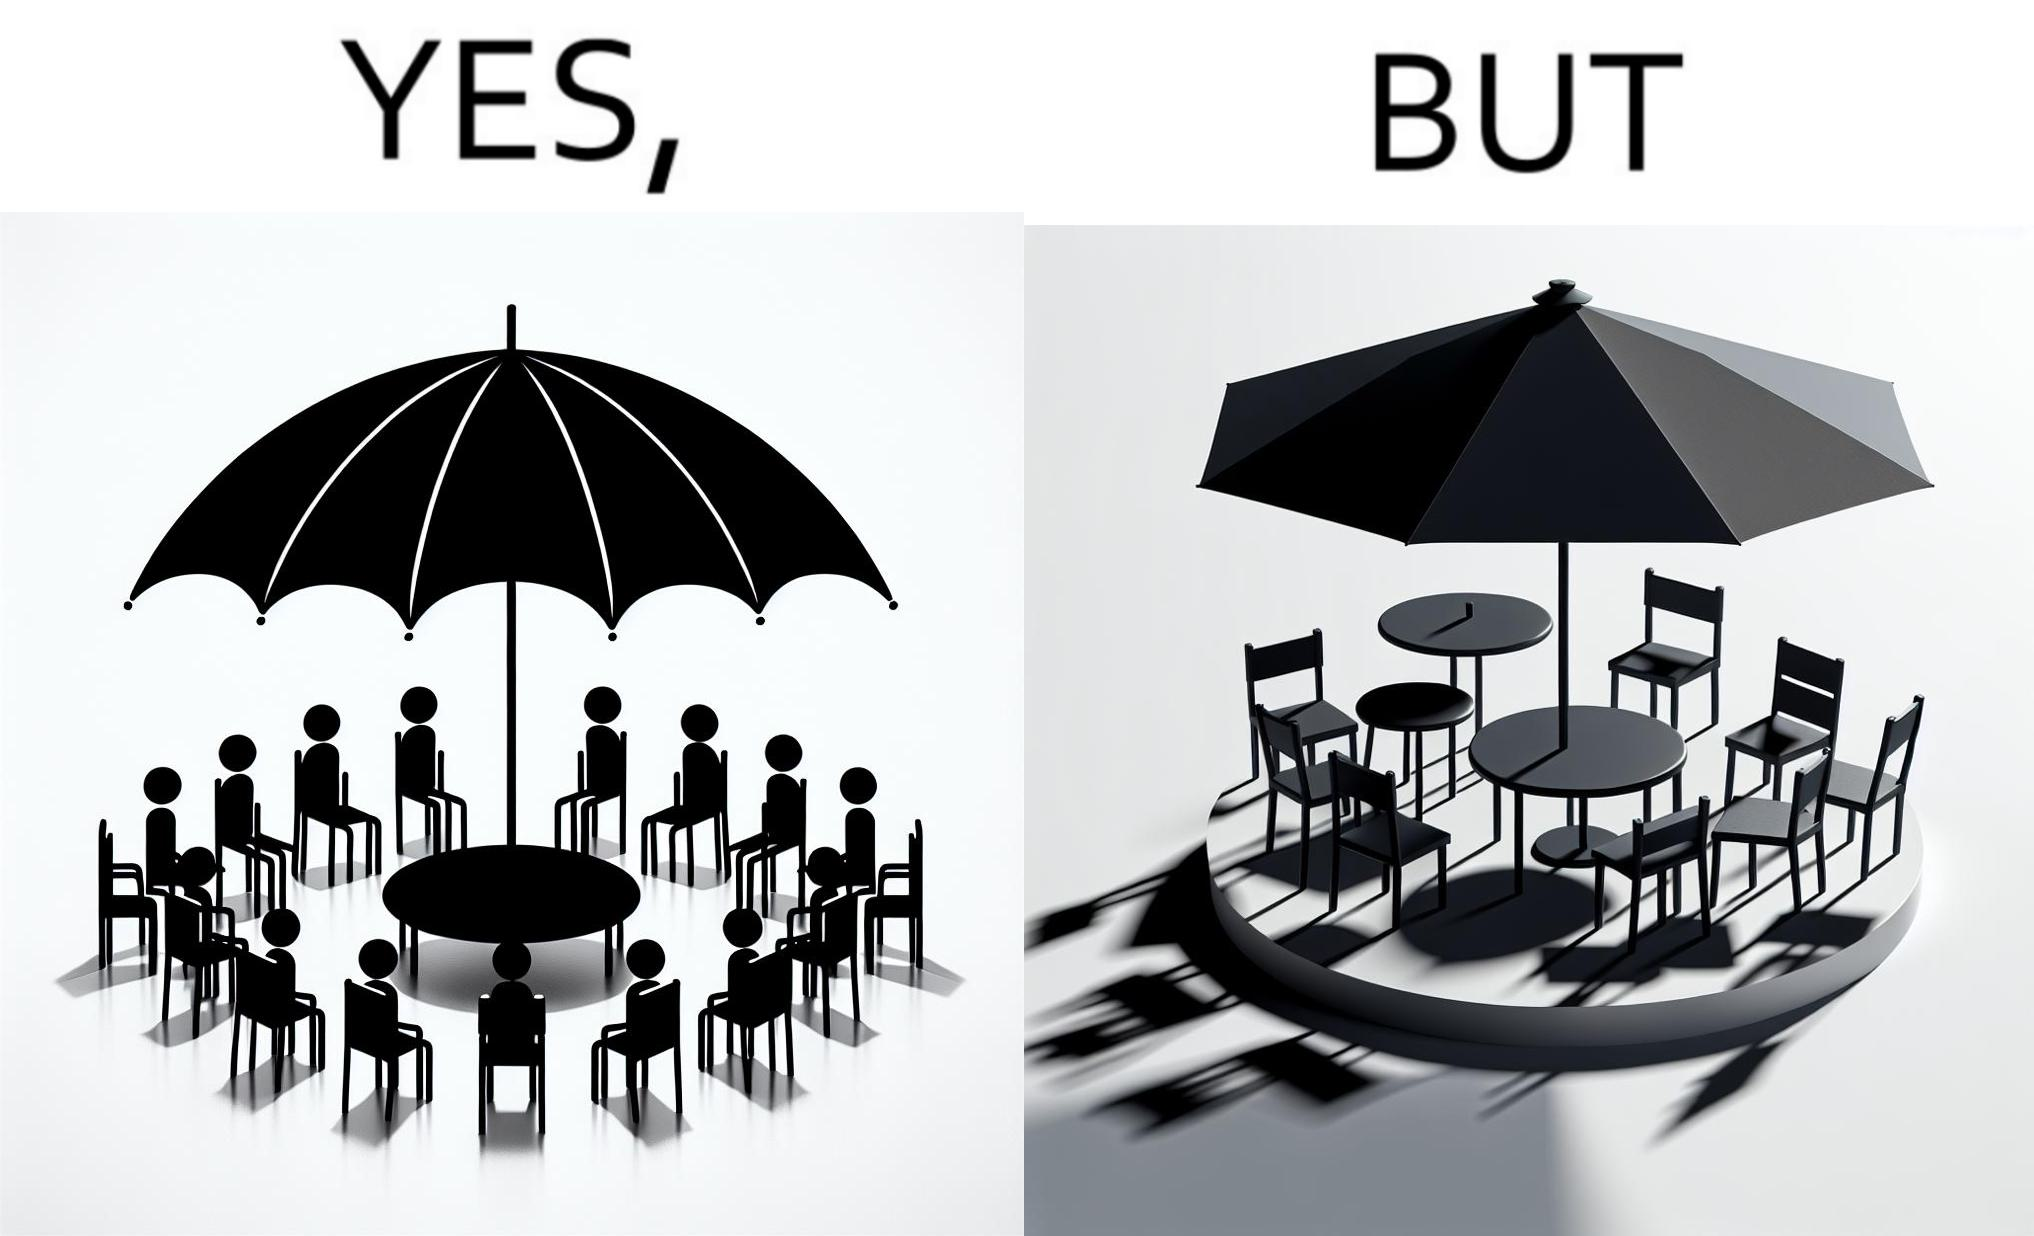Describe the contrast between the left and right parts of this image. In the left part of the image: Chairs surrounding a table under a large umbrella. In the right part of the image: Chairs surrounding a table under a large umbrella, with the shadow of the umbrella appearing on the side. 